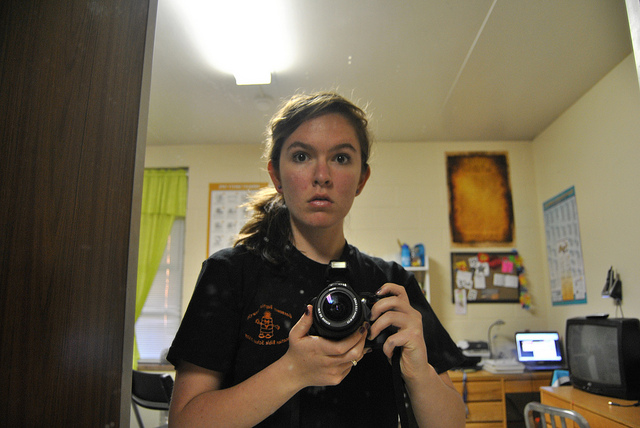<image>Who is in the pictures on the wall? I don't know who is in the pictures on the wall. It could be anyone from god, a pharaoh, friends, people, or Jesus. What is on the woman's left arm? I am not sure what is on the woman's left arm. It can be a camera or a sleeve. Who is in the pictures on the wall? I don't know who is in the pictures on the wall. It can be seen 'no one', 'poster', 'pharaoh', 'friends', 'people' or 'jesus'. What is on the woman's left arm? I am not sure what is on the woman's left arm. It can be seen 't shirt sleeve', 'camera', 'shirt', or 'nothing'. 